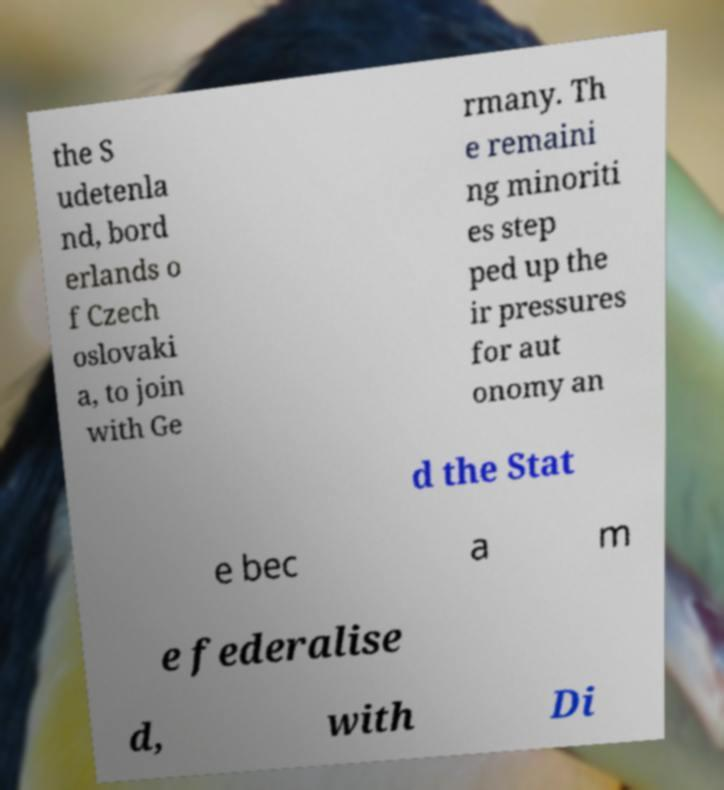Could you extract and type out the text from this image? the S udetenla nd, bord erlands o f Czech oslovaki a, to join with Ge rmany. Th e remaini ng minoriti es step ped up the ir pressures for aut onomy an d the Stat e bec a m e federalise d, with Di 